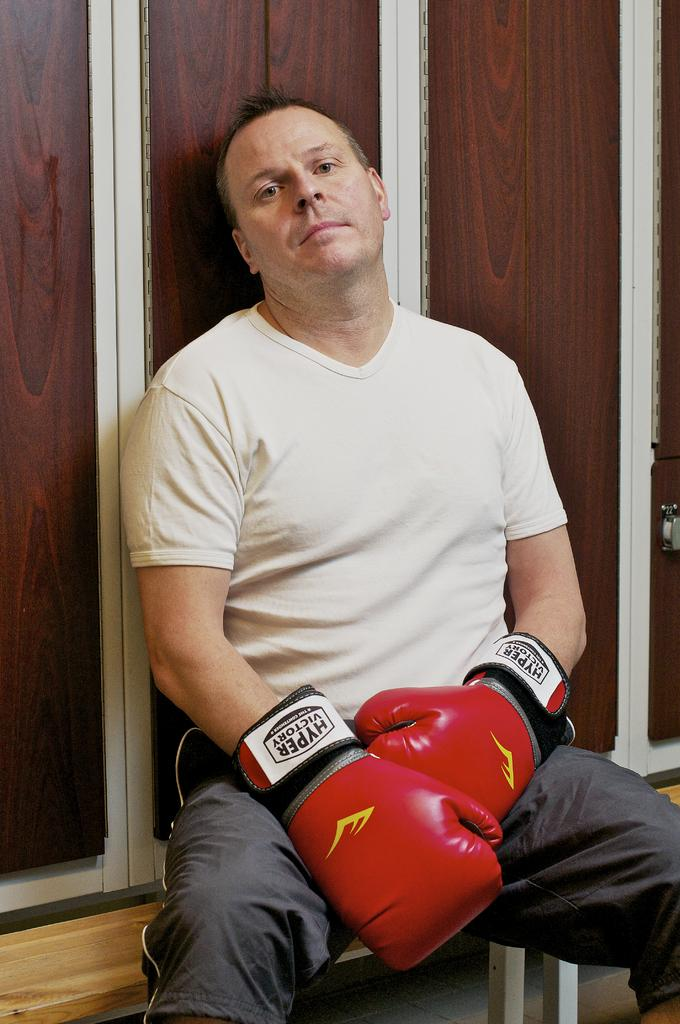Who or what is present in the image? There is a person in the image. What is the person doing in the image? The person is sitting on an object. What can be seen on the person's hands? The person is wearing boxing gloves. What type of material can be seen in the background of the image? There is a wooden wall in the background of the image. How many boats can be seen in the image? There are no boats present in the image. What color are the person's toes in the image? The person's toes are not visible in the image, as they are wearing boxing gloves. 